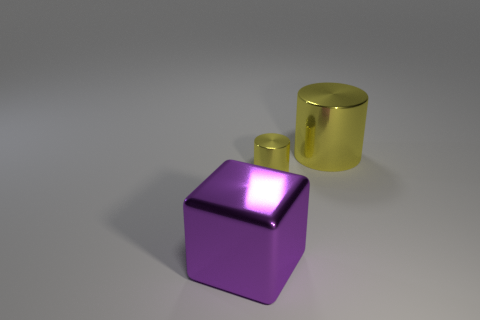Add 1 purple metallic cubes. How many objects exist? 4 Subtract all blocks. How many objects are left? 2 Add 2 blue rubber balls. How many blue rubber balls exist? 2 Subtract 1 purple blocks. How many objects are left? 2 Subtract all red cubes. Subtract all big cylinders. How many objects are left? 2 Add 1 tiny cylinders. How many tiny cylinders are left? 2 